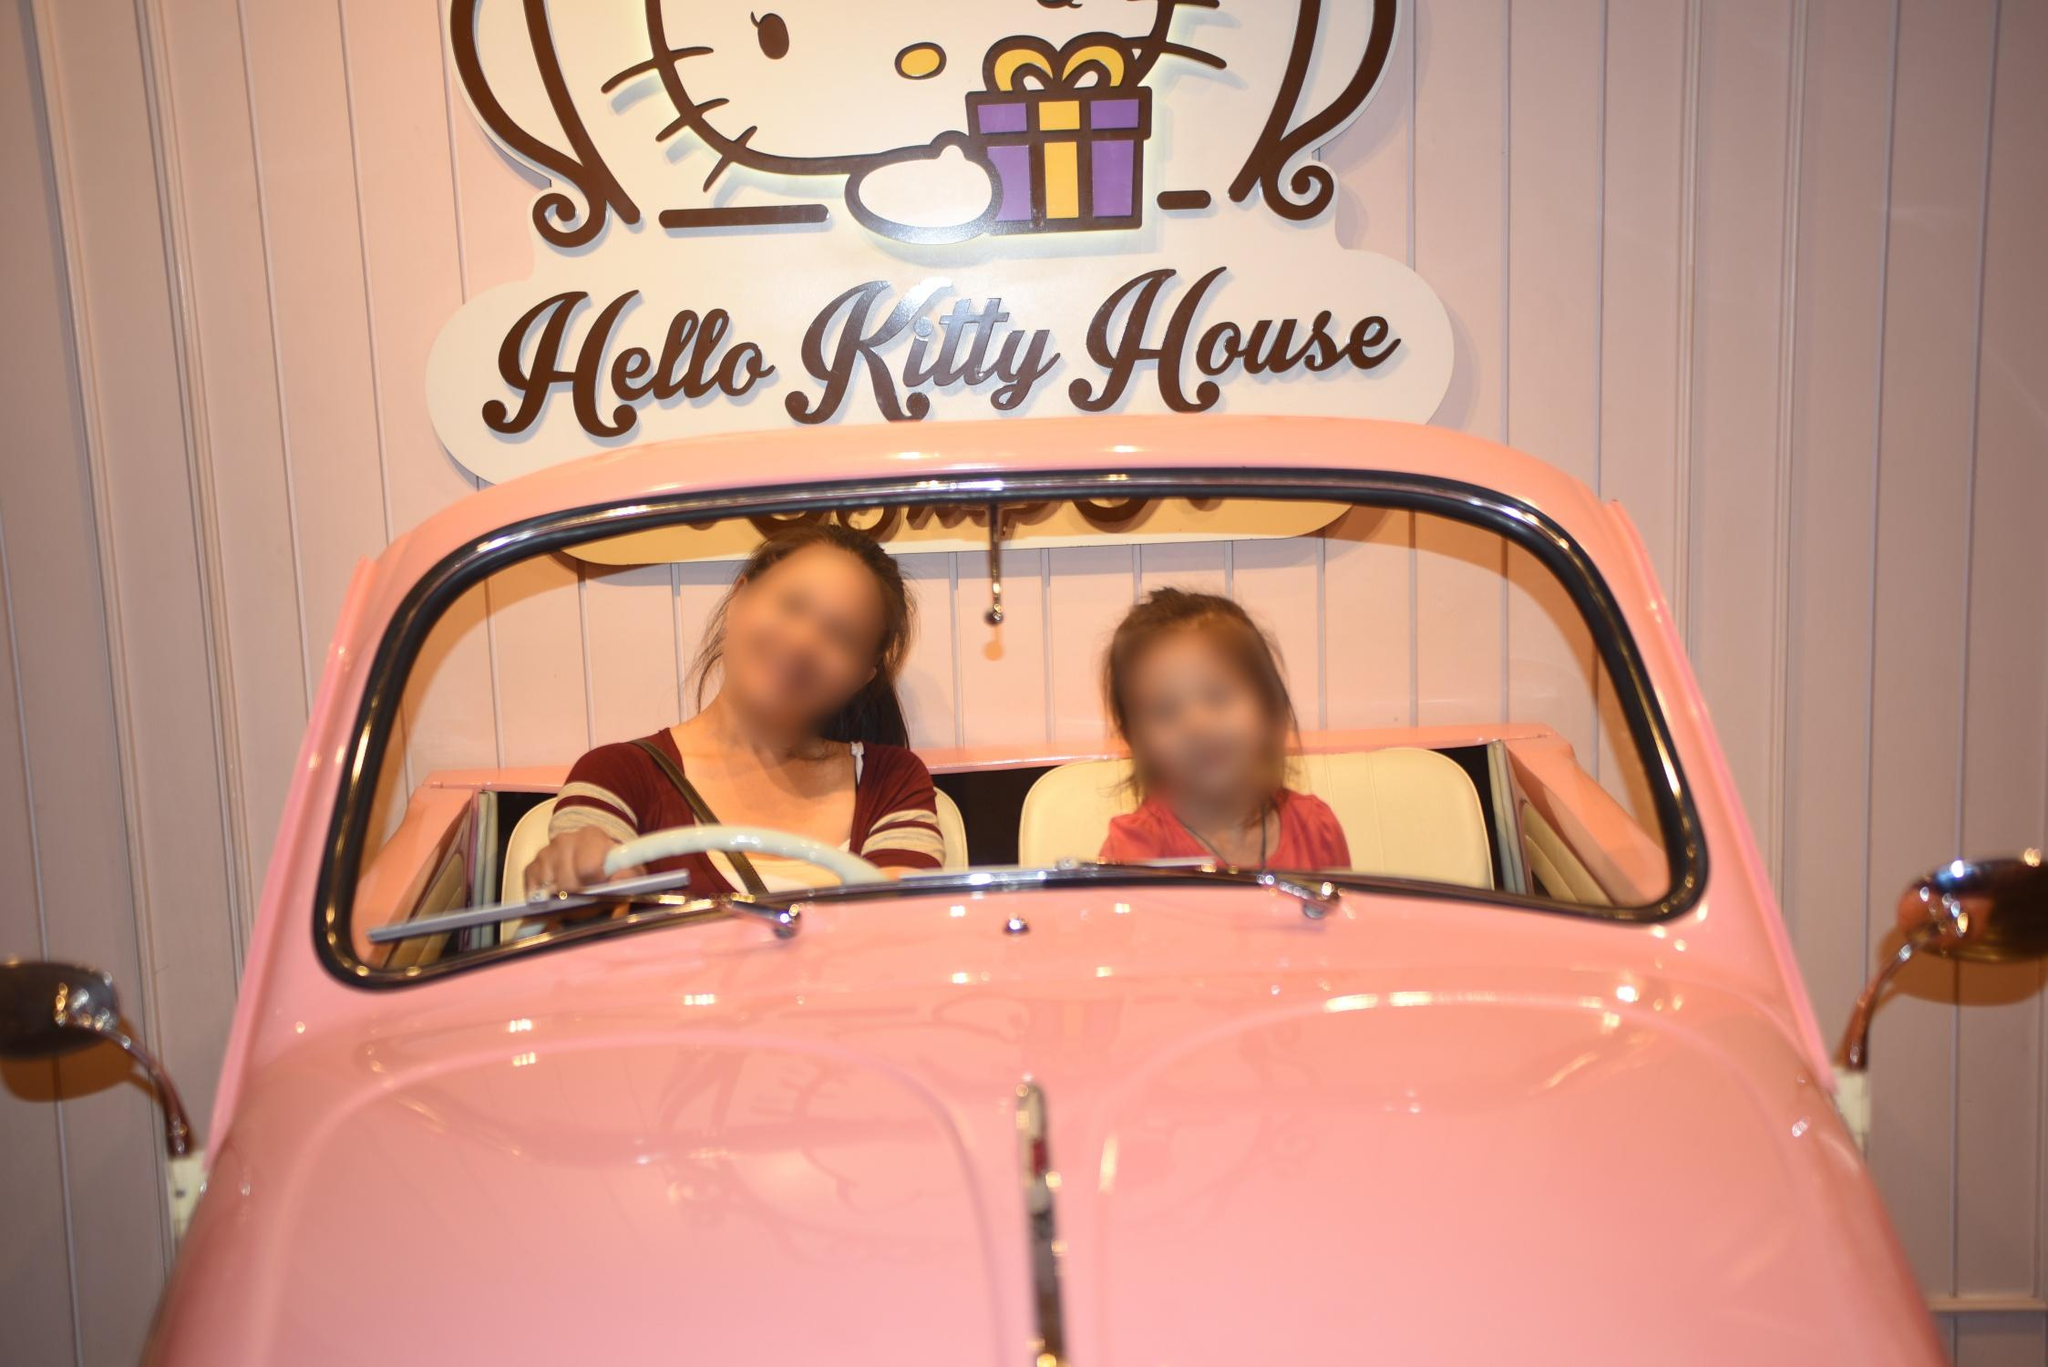Is this an actual car model or just a prop for photo opportunities? Without more context, it's difficult to determine whether the car is functional or solely a prop. However, given the emphasis on thematic consistency and the playful nature of the setting, it is likely that the car serves primarily as a photogenic prop within the Hello Kitty House to enhance the visitor experience. 